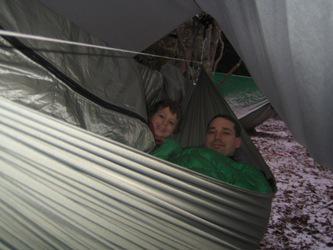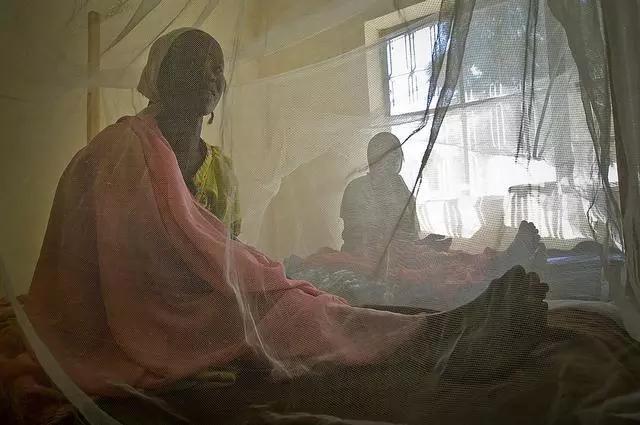The first image is the image on the left, the second image is the image on the right. Evaluate the accuracy of this statement regarding the images: "An image includes a young baby sleeping under a protective net.". Is it true? Answer yes or no. No. 